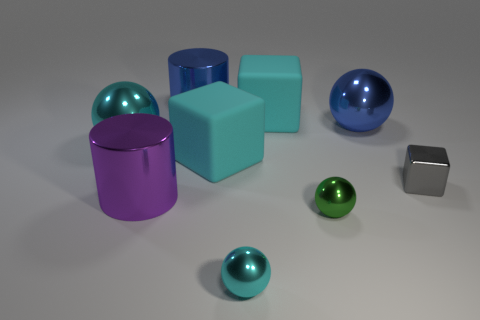Does the big thing that is in front of the tiny shiny block have the same shape as the green thing?
Offer a terse response. No. What is the gray thing made of?
Make the answer very short. Metal. The green thing that is the same size as the metal cube is what shape?
Your answer should be very brief. Sphere. Are there any tiny shiny balls that have the same color as the tiny shiny block?
Make the answer very short. No. Do the tiny cube and the big rubber thing in front of the big cyan metallic sphere have the same color?
Offer a very short reply. No. What is the color of the block that is to the left of the cyan metal ball that is in front of the tiny gray metallic cube?
Keep it short and to the point. Cyan. There is a shiny cylinder that is right of the large cylinder that is in front of the small gray object; is there a large cyan metal sphere that is right of it?
Provide a succinct answer. No. There is a tiny block that is made of the same material as the tiny green ball; what color is it?
Provide a succinct answer. Gray. What number of spheres are made of the same material as the purple thing?
Your answer should be compact. 4. Is the material of the small gray block the same as the big cylinder that is in front of the small gray cube?
Your answer should be very brief. Yes. 